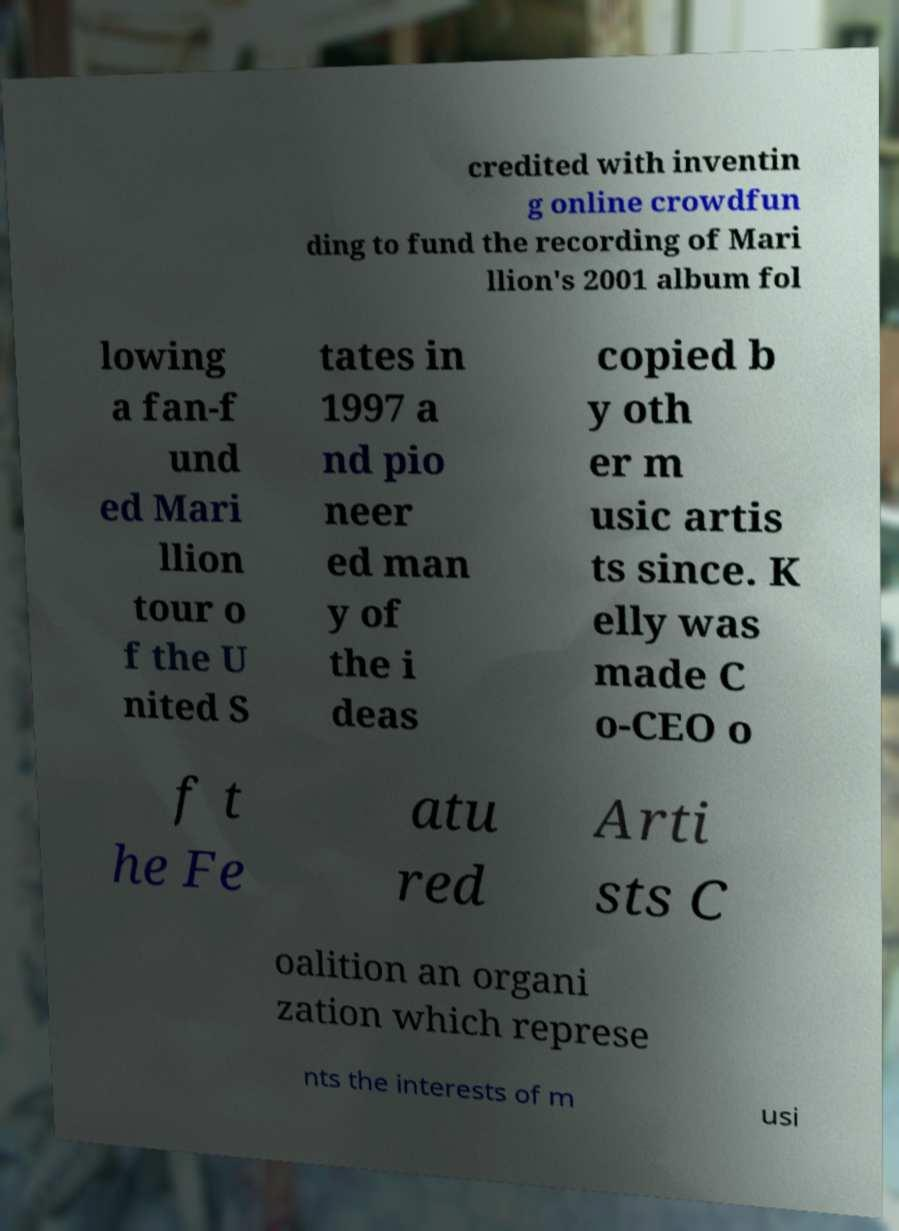Could you assist in decoding the text presented in this image and type it out clearly? credited with inventin g online crowdfun ding to fund the recording of Mari llion's 2001 album fol lowing a fan-f und ed Mari llion tour o f the U nited S tates in 1997 a nd pio neer ed man y of the i deas copied b y oth er m usic artis ts since. K elly was made C o-CEO o f t he Fe atu red Arti sts C oalition an organi zation which represe nts the interests of m usi 